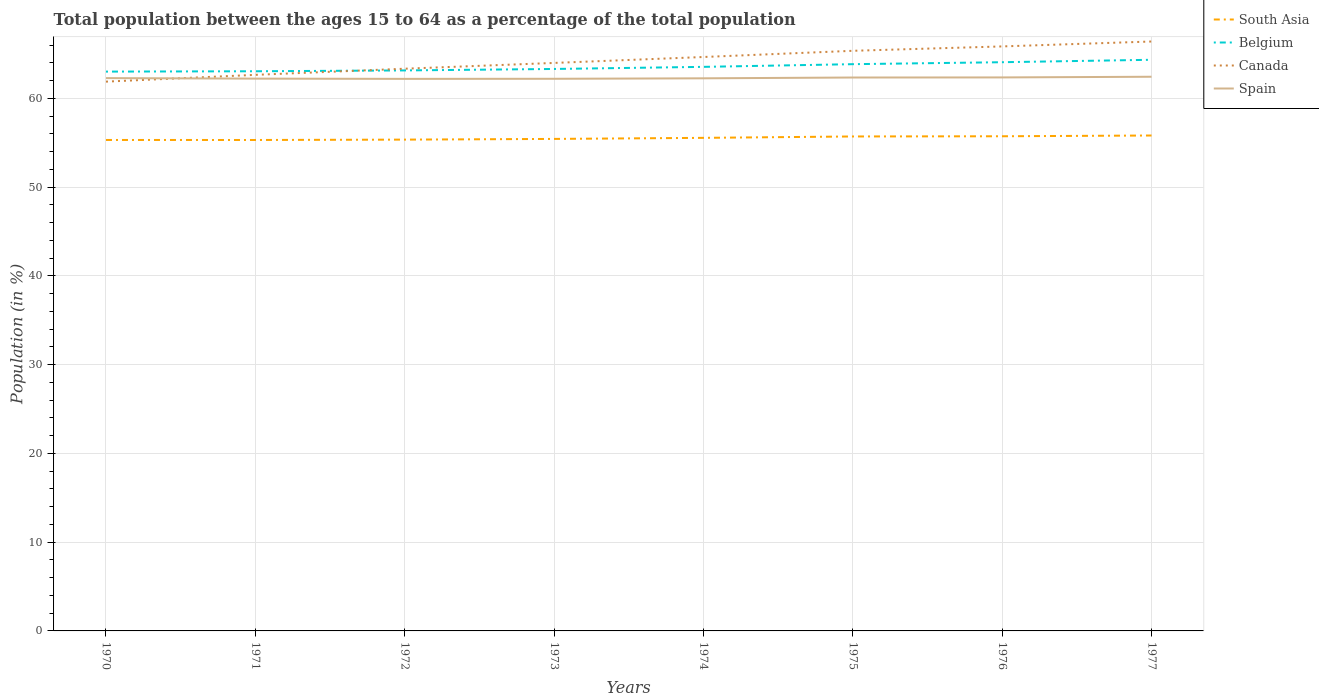Across all years, what is the maximum percentage of the population ages 15 to 64 in South Asia?
Make the answer very short. 55.31. What is the total percentage of the population ages 15 to 64 in South Asia in the graph?
Your answer should be very brief. -0.12. What is the difference between the highest and the second highest percentage of the population ages 15 to 64 in Belgium?
Keep it short and to the point. 1.33. Is the percentage of the population ages 15 to 64 in Spain strictly greater than the percentage of the population ages 15 to 64 in Belgium over the years?
Your answer should be compact. Yes. How many lines are there?
Your answer should be very brief. 4. Does the graph contain grids?
Offer a very short reply. Yes. How many legend labels are there?
Give a very brief answer. 4. How are the legend labels stacked?
Your response must be concise. Vertical. What is the title of the graph?
Your answer should be very brief. Total population between the ages 15 to 64 as a percentage of the total population. Does "United Arab Emirates" appear as one of the legend labels in the graph?
Keep it short and to the point. No. What is the label or title of the Y-axis?
Your answer should be compact. Population (in %). What is the Population (in %) in South Asia in 1970?
Offer a very short reply. 55.31. What is the Population (in %) in Belgium in 1970?
Your answer should be very brief. 63.02. What is the Population (in %) of Canada in 1970?
Make the answer very short. 61.89. What is the Population (in %) in Spain in 1970?
Your answer should be very brief. 62.28. What is the Population (in %) of South Asia in 1971?
Keep it short and to the point. 55.31. What is the Population (in %) in Belgium in 1971?
Keep it short and to the point. 63.05. What is the Population (in %) of Canada in 1971?
Give a very brief answer. 62.65. What is the Population (in %) in Spain in 1971?
Provide a succinct answer. 62.23. What is the Population (in %) of South Asia in 1972?
Keep it short and to the point. 55.35. What is the Population (in %) in Belgium in 1972?
Make the answer very short. 63.15. What is the Population (in %) in Canada in 1972?
Your answer should be very brief. 63.34. What is the Population (in %) in Spain in 1972?
Your answer should be compact. 62.2. What is the Population (in %) in South Asia in 1973?
Provide a succinct answer. 55.43. What is the Population (in %) of Belgium in 1973?
Offer a very short reply. 63.31. What is the Population (in %) of Canada in 1973?
Give a very brief answer. 63.99. What is the Population (in %) of Spain in 1973?
Your answer should be very brief. 62.21. What is the Population (in %) in South Asia in 1974?
Make the answer very short. 55.55. What is the Population (in %) of Belgium in 1974?
Offer a terse response. 63.55. What is the Population (in %) in Canada in 1974?
Your answer should be compact. 64.66. What is the Population (in %) in Spain in 1974?
Your answer should be compact. 62.26. What is the Population (in %) of South Asia in 1975?
Offer a very short reply. 55.71. What is the Population (in %) of Belgium in 1975?
Provide a succinct answer. 63.85. What is the Population (in %) in Canada in 1975?
Provide a succinct answer. 65.36. What is the Population (in %) in Spain in 1975?
Offer a very short reply. 62.35. What is the Population (in %) in South Asia in 1976?
Your answer should be very brief. 55.73. What is the Population (in %) in Belgium in 1976?
Your answer should be very brief. 64.07. What is the Population (in %) in Canada in 1976?
Offer a very short reply. 65.85. What is the Population (in %) of Spain in 1976?
Give a very brief answer. 62.36. What is the Population (in %) of South Asia in 1977?
Keep it short and to the point. 55.82. What is the Population (in %) of Belgium in 1977?
Provide a succinct answer. 64.35. What is the Population (in %) of Canada in 1977?
Provide a succinct answer. 66.41. What is the Population (in %) of Spain in 1977?
Provide a short and direct response. 62.44. Across all years, what is the maximum Population (in %) of South Asia?
Your answer should be very brief. 55.82. Across all years, what is the maximum Population (in %) in Belgium?
Offer a very short reply. 64.35. Across all years, what is the maximum Population (in %) in Canada?
Offer a terse response. 66.41. Across all years, what is the maximum Population (in %) in Spain?
Make the answer very short. 62.44. Across all years, what is the minimum Population (in %) in South Asia?
Offer a very short reply. 55.31. Across all years, what is the minimum Population (in %) of Belgium?
Your answer should be compact. 63.02. Across all years, what is the minimum Population (in %) in Canada?
Give a very brief answer. 61.89. Across all years, what is the minimum Population (in %) of Spain?
Give a very brief answer. 62.2. What is the total Population (in %) in South Asia in the graph?
Your response must be concise. 444.22. What is the total Population (in %) of Belgium in the graph?
Offer a very short reply. 508.36. What is the total Population (in %) in Canada in the graph?
Your answer should be compact. 514.16. What is the total Population (in %) of Spain in the graph?
Provide a short and direct response. 498.33. What is the difference between the Population (in %) in South Asia in 1970 and that in 1971?
Provide a short and direct response. 0. What is the difference between the Population (in %) of Belgium in 1970 and that in 1971?
Your answer should be compact. -0.04. What is the difference between the Population (in %) in Canada in 1970 and that in 1971?
Offer a very short reply. -0.76. What is the difference between the Population (in %) in Spain in 1970 and that in 1971?
Make the answer very short. 0.06. What is the difference between the Population (in %) of South Asia in 1970 and that in 1972?
Give a very brief answer. -0.04. What is the difference between the Population (in %) of Belgium in 1970 and that in 1972?
Give a very brief answer. -0.13. What is the difference between the Population (in %) in Canada in 1970 and that in 1972?
Your answer should be very brief. -1.45. What is the difference between the Population (in %) in Spain in 1970 and that in 1972?
Provide a short and direct response. 0.09. What is the difference between the Population (in %) of South Asia in 1970 and that in 1973?
Offer a terse response. -0.12. What is the difference between the Population (in %) of Belgium in 1970 and that in 1973?
Keep it short and to the point. -0.3. What is the difference between the Population (in %) in Canada in 1970 and that in 1973?
Give a very brief answer. -2.11. What is the difference between the Population (in %) in Spain in 1970 and that in 1973?
Provide a succinct answer. 0.08. What is the difference between the Population (in %) of South Asia in 1970 and that in 1974?
Offer a terse response. -0.24. What is the difference between the Population (in %) in Belgium in 1970 and that in 1974?
Offer a very short reply. -0.53. What is the difference between the Population (in %) of Canada in 1970 and that in 1974?
Offer a terse response. -2.78. What is the difference between the Population (in %) of Spain in 1970 and that in 1974?
Provide a short and direct response. 0.02. What is the difference between the Population (in %) of South Asia in 1970 and that in 1975?
Ensure brevity in your answer.  -0.39. What is the difference between the Population (in %) in Belgium in 1970 and that in 1975?
Keep it short and to the point. -0.84. What is the difference between the Population (in %) in Canada in 1970 and that in 1975?
Offer a terse response. -3.47. What is the difference between the Population (in %) of Spain in 1970 and that in 1975?
Provide a short and direct response. -0.07. What is the difference between the Population (in %) of South Asia in 1970 and that in 1976?
Make the answer very short. -0.42. What is the difference between the Population (in %) in Belgium in 1970 and that in 1976?
Ensure brevity in your answer.  -1.06. What is the difference between the Population (in %) in Canada in 1970 and that in 1976?
Your answer should be compact. -3.97. What is the difference between the Population (in %) in Spain in 1970 and that in 1976?
Your response must be concise. -0.08. What is the difference between the Population (in %) of South Asia in 1970 and that in 1977?
Your answer should be compact. -0.5. What is the difference between the Population (in %) of Belgium in 1970 and that in 1977?
Your answer should be compact. -1.33. What is the difference between the Population (in %) in Canada in 1970 and that in 1977?
Make the answer very short. -4.52. What is the difference between the Population (in %) in Spain in 1970 and that in 1977?
Your answer should be very brief. -0.15. What is the difference between the Population (in %) of South Asia in 1971 and that in 1972?
Give a very brief answer. -0.04. What is the difference between the Population (in %) in Belgium in 1971 and that in 1972?
Offer a very short reply. -0.1. What is the difference between the Population (in %) in Canada in 1971 and that in 1972?
Ensure brevity in your answer.  -0.69. What is the difference between the Population (in %) of Spain in 1971 and that in 1972?
Your answer should be compact. 0.03. What is the difference between the Population (in %) in South Asia in 1971 and that in 1973?
Your answer should be very brief. -0.12. What is the difference between the Population (in %) in Belgium in 1971 and that in 1973?
Offer a terse response. -0.26. What is the difference between the Population (in %) of Canada in 1971 and that in 1973?
Offer a very short reply. -1.34. What is the difference between the Population (in %) in Spain in 1971 and that in 1973?
Provide a succinct answer. 0.02. What is the difference between the Population (in %) in South Asia in 1971 and that in 1974?
Give a very brief answer. -0.24. What is the difference between the Population (in %) of Belgium in 1971 and that in 1974?
Offer a very short reply. -0.5. What is the difference between the Population (in %) of Canada in 1971 and that in 1974?
Provide a short and direct response. -2.01. What is the difference between the Population (in %) of Spain in 1971 and that in 1974?
Ensure brevity in your answer.  -0.03. What is the difference between the Population (in %) of South Asia in 1971 and that in 1975?
Offer a terse response. -0.4. What is the difference between the Population (in %) in Belgium in 1971 and that in 1975?
Your response must be concise. -0.8. What is the difference between the Population (in %) in Canada in 1971 and that in 1975?
Offer a very short reply. -2.71. What is the difference between the Population (in %) in Spain in 1971 and that in 1975?
Provide a short and direct response. -0.12. What is the difference between the Population (in %) of South Asia in 1971 and that in 1976?
Your answer should be very brief. -0.42. What is the difference between the Population (in %) in Belgium in 1971 and that in 1976?
Provide a short and direct response. -1.02. What is the difference between the Population (in %) in Canada in 1971 and that in 1976?
Offer a terse response. -3.2. What is the difference between the Population (in %) in Spain in 1971 and that in 1976?
Provide a succinct answer. -0.14. What is the difference between the Population (in %) of South Asia in 1971 and that in 1977?
Ensure brevity in your answer.  -0.51. What is the difference between the Population (in %) of Belgium in 1971 and that in 1977?
Your answer should be compact. -1.29. What is the difference between the Population (in %) of Canada in 1971 and that in 1977?
Make the answer very short. -3.76. What is the difference between the Population (in %) of Spain in 1971 and that in 1977?
Offer a terse response. -0.21. What is the difference between the Population (in %) of South Asia in 1972 and that in 1973?
Give a very brief answer. -0.08. What is the difference between the Population (in %) of Belgium in 1972 and that in 1973?
Ensure brevity in your answer.  -0.16. What is the difference between the Population (in %) in Canada in 1972 and that in 1973?
Provide a succinct answer. -0.65. What is the difference between the Population (in %) of Spain in 1972 and that in 1973?
Your answer should be compact. -0.01. What is the difference between the Population (in %) in South Asia in 1972 and that in 1974?
Ensure brevity in your answer.  -0.2. What is the difference between the Population (in %) of Belgium in 1972 and that in 1974?
Provide a succinct answer. -0.4. What is the difference between the Population (in %) of Canada in 1972 and that in 1974?
Provide a short and direct response. -1.32. What is the difference between the Population (in %) of Spain in 1972 and that in 1974?
Give a very brief answer. -0.06. What is the difference between the Population (in %) of South Asia in 1972 and that in 1975?
Keep it short and to the point. -0.36. What is the difference between the Population (in %) in Belgium in 1972 and that in 1975?
Provide a succinct answer. -0.7. What is the difference between the Population (in %) of Canada in 1972 and that in 1975?
Your response must be concise. -2.02. What is the difference between the Population (in %) of Spain in 1972 and that in 1975?
Your response must be concise. -0.15. What is the difference between the Population (in %) of South Asia in 1972 and that in 1976?
Provide a succinct answer. -0.38. What is the difference between the Population (in %) in Belgium in 1972 and that in 1976?
Provide a succinct answer. -0.92. What is the difference between the Population (in %) in Canada in 1972 and that in 1976?
Offer a very short reply. -2.51. What is the difference between the Population (in %) of Spain in 1972 and that in 1976?
Ensure brevity in your answer.  -0.16. What is the difference between the Population (in %) in South Asia in 1972 and that in 1977?
Give a very brief answer. -0.46. What is the difference between the Population (in %) in Belgium in 1972 and that in 1977?
Make the answer very short. -1.2. What is the difference between the Population (in %) in Canada in 1972 and that in 1977?
Provide a short and direct response. -3.07. What is the difference between the Population (in %) of Spain in 1972 and that in 1977?
Keep it short and to the point. -0.24. What is the difference between the Population (in %) in South Asia in 1973 and that in 1974?
Ensure brevity in your answer.  -0.12. What is the difference between the Population (in %) of Belgium in 1973 and that in 1974?
Make the answer very short. -0.24. What is the difference between the Population (in %) of Canada in 1973 and that in 1974?
Your response must be concise. -0.67. What is the difference between the Population (in %) of Spain in 1973 and that in 1974?
Offer a terse response. -0.05. What is the difference between the Population (in %) of South Asia in 1973 and that in 1975?
Your answer should be very brief. -0.28. What is the difference between the Population (in %) of Belgium in 1973 and that in 1975?
Offer a very short reply. -0.54. What is the difference between the Population (in %) of Canada in 1973 and that in 1975?
Give a very brief answer. -1.37. What is the difference between the Population (in %) in Spain in 1973 and that in 1975?
Your answer should be very brief. -0.14. What is the difference between the Population (in %) in South Asia in 1973 and that in 1976?
Provide a succinct answer. -0.3. What is the difference between the Population (in %) in Belgium in 1973 and that in 1976?
Your answer should be very brief. -0.76. What is the difference between the Population (in %) in Canada in 1973 and that in 1976?
Ensure brevity in your answer.  -1.86. What is the difference between the Population (in %) of Spain in 1973 and that in 1976?
Make the answer very short. -0.15. What is the difference between the Population (in %) of South Asia in 1973 and that in 1977?
Give a very brief answer. -0.38. What is the difference between the Population (in %) in Belgium in 1973 and that in 1977?
Make the answer very short. -1.03. What is the difference between the Population (in %) in Canada in 1973 and that in 1977?
Your answer should be very brief. -2.41. What is the difference between the Population (in %) in Spain in 1973 and that in 1977?
Offer a very short reply. -0.23. What is the difference between the Population (in %) of South Asia in 1974 and that in 1975?
Ensure brevity in your answer.  -0.16. What is the difference between the Population (in %) in Belgium in 1974 and that in 1975?
Give a very brief answer. -0.3. What is the difference between the Population (in %) in Canada in 1974 and that in 1975?
Ensure brevity in your answer.  -0.7. What is the difference between the Population (in %) in Spain in 1974 and that in 1975?
Give a very brief answer. -0.09. What is the difference between the Population (in %) of South Asia in 1974 and that in 1976?
Your response must be concise. -0.18. What is the difference between the Population (in %) in Belgium in 1974 and that in 1976?
Give a very brief answer. -0.52. What is the difference between the Population (in %) in Canada in 1974 and that in 1976?
Your answer should be very brief. -1.19. What is the difference between the Population (in %) of Spain in 1974 and that in 1976?
Your answer should be very brief. -0.1. What is the difference between the Population (in %) of South Asia in 1974 and that in 1977?
Give a very brief answer. -0.26. What is the difference between the Population (in %) in Belgium in 1974 and that in 1977?
Keep it short and to the point. -0.8. What is the difference between the Population (in %) in Canada in 1974 and that in 1977?
Your answer should be very brief. -1.75. What is the difference between the Population (in %) in Spain in 1974 and that in 1977?
Your answer should be compact. -0.18. What is the difference between the Population (in %) in South Asia in 1975 and that in 1976?
Offer a very short reply. -0.02. What is the difference between the Population (in %) of Belgium in 1975 and that in 1976?
Offer a very short reply. -0.22. What is the difference between the Population (in %) in Canada in 1975 and that in 1976?
Your answer should be compact. -0.49. What is the difference between the Population (in %) of Spain in 1975 and that in 1976?
Your answer should be compact. -0.01. What is the difference between the Population (in %) of South Asia in 1975 and that in 1977?
Ensure brevity in your answer.  -0.11. What is the difference between the Population (in %) in Belgium in 1975 and that in 1977?
Keep it short and to the point. -0.5. What is the difference between the Population (in %) of Canada in 1975 and that in 1977?
Offer a terse response. -1.05. What is the difference between the Population (in %) of Spain in 1975 and that in 1977?
Provide a short and direct response. -0.09. What is the difference between the Population (in %) in South Asia in 1976 and that in 1977?
Give a very brief answer. -0.09. What is the difference between the Population (in %) in Belgium in 1976 and that in 1977?
Give a very brief answer. -0.27. What is the difference between the Population (in %) in Canada in 1976 and that in 1977?
Your response must be concise. -0.55. What is the difference between the Population (in %) in Spain in 1976 and that in 1977?
Your answer should be very brief. -0.08. What is the difference between the Population (in %) of South Asia in 1970 and the Population (in %) of Belgium in 1971?
Offer a very short reply. -7.74. What is the difference between the Population (in %) of South Asia in 1970 and the Population (in %) of Canada in 1971?
Your answer should be very brief. -7.34. What is the difference between the Population (in %) of South Asia in 1970 and the Population (in %) of Spain in 1971?
Offer a very short reply. -6.91. What is the difference between the Population (in %) in Belgium in 1970 and the Population (in %) in Canada in 1971?
Keep it short and to the point. 0.36. What is the difference between the Population (in %) of Belgium in 1970 and the Population (in %) of Spain in 1971?
Provide a succinct answer. 0.79. What is the difference between the Population (in %) of Canada in 1970 and the Population (in %) of Spain in 1971?
Keep it short and to the point. -0.34. What is the difference between the Population (in %) in South Asia in 1970 and the Population (in %) in Belgium in 1972?
Provide a succinct answer. -7.84. What is the difference between the Population (in %) of South Asia in 1970 and the Population (in %) of Canada in 1972?
Make the answer very short. -8.03. What is the difference between the Population (in %) in South Asia in 1970 and the Population (in %) in Spain in 1972?
Ensure brevity in your answer.  -6.88. What is the difference between the Population (in %) of Belgium in 1970 and the Population (in %) of Canada in 1972?
Keep it short and to the point. -0.33. What is the difference between the Population (in %) of Belgium in 1970 and the Population (in %) of Spain in 1972?
Keep it short and to the point. 0.82. What is the difference between the Population (in %) in Canada in 1970 and the Population (in %) in Spain in 1972?
Provide a short and direct response. -0.31. What is the difference between the Population (in %) in South Asia in 1970 and the Population (in %) in Belgium in 1973?
Your response must be concise. -8. What is the difference between the Population (in %) in South Asia in 1970 and the Population (in %) in Canada in 1973?
Offer a terse response. -8.68. What is the difference between the Population (in %) of South Asia in 1970 and the Population (in %) of Spain in 1973?
Provide a short and direct response. -6.89. What is the difference between the Population (in %) in Belgium in 1970 and the Population (in %) in Canada in 1973?
Offer a terse response. -0.98. What is the difference between the Population (in %) of Belgium in 1970 and the Population (in %) of Spain in 1973?
Give a very brief answer. 0.81. What is the difference between the Population (in %) of Canada in 1970 and the Population (in %) of Spain in 1973?
Your response must be concise. -0.32. What is the difference between the Population (in %) in South Asia in 1970 and the Population (in %) in Belgium in 1974?
Your answer should be compact. -8.24. What is the difference between the Population (in %) of South Asia in 1970 and the Population (in %) of Canada in 1974?
Provide a short and direct response. -9.35. What is the difference between the Population (in %) of South Asia in 1970 and the Population (in %) of Spain in 1974?
Give a very brief answer. -6.95. What is the difference between the Population (in %) of Belgium in 1970 and the Population (in %) of Canada in 1974?
Make the answer very short. -1.65. What is the difference between the Population (in %) of Belgium in 1970 and the Population (in %) of Spain in 1974?
Provide a short and direct response. 0.76. What is the difference between the Population (in %) of Canada in 1970 and the Population (in %) of Spain in 1974?
Provide a succinct answer. -0.37. What is the difference between the Population (in %) in South Asia in 1970 and the Population (in %) in Belgium in 1975?
Make the answer very short. -8.54. What is the difference between the Population (in %) of South Asia in 1970 and the Population (in %) of Canada in 1975?
Keep it short and to the point. -10.05. What is the difference between the Population (in %) in South Asia in 1970 and the Population (in %) in Spain in 1975?
Provide a short and direct response. -7.04. What is the difference between the Population (in %) in Belgium in 1970 and the Population (in %) in Canada in 1975?
Offer a very short reply. -2.34. What is the difference between the Population (in %) of Belgium in 1970 and the Population (in %) of Spain in 1975?
Give a very brief answer. 0.67. What is the difference between the Population (in %) of Canada in 1970 and the Population (in %) of Spain in 1975?
Ensure brevity in your answer.  -0.46. What is the difference between the Population (in %) of South Asia in 1970 and the Population (in %) of Belgium in 1976?
Provide a short and direct response. -8.76. What is the difference between the Population (in %) in South Asia in 1970 and the Population (in %) in Canada in 1976?
Make the answer very short. -10.54. What is the difference between the Population (in %) in South Asia in 1970 and the Population (in %) in Spain in 1976?
Provide a succinct answer. -7.05. What is the difference between the Population (in %) in Belgium in 1970 and the Population (in %) in Canada in 1976?
Your answer should be very brief. -2.84. What is the difference between the Population (in %) of Belgium in 1970 and the Population (in %) of Spain in 1976?
Your response must be concise. 0.65. What is the difference between the Population (in %) of Canada in 1970 and the Population (in %) of Spain in 1976?
Make the answer very short. -0.47. What is the difference between the Population (in %) of South Asia in 1970 and the Population (in %) of Belgium in 1977?
Provide a short and direct response. -9.03. What is the difference between the Population (in %) of South Asia in 1970 and the Population (in %) of Canada in 1977?
Keep it short and to the point. -11.09. What is the difference between the Population (in %) of South Asia in 1970 and the Population (in %) of Spain in 1977?
Give a very brief answer. -7.12. What is the difference between the Population (in %) in Belgium in 1970 and the Population (in %) in Canada in 1977?
Your answer should be compact. -3.39. What is the difference between the Population (in %) of Belgium in 1970 and the Population (in %) of Spain in 1977?
Your response must be concise. 0.58. What is the difference between the Population (in %) of Canada in 1970 and the Population (in %) of Spain in 1977?
Your response must be concise. -0.55. What is the difference between the Population (in %) in South Asia in 1971 and the Population (in %) in Belgium in 1972?
Provide a succinct answer. -7.84. What is the difference between the Population (in %) in South Asia in 1971 and the Population (in %) in Canada in 1972?
Ensure brevity in your answer.  -8.03. What is the difference between the Population (in %) of South Asia in 1971 and the Population (in %) of Spain in 1972?
Your answer should be compact. -6.89. What is the difference between the Population (in %) in Belgium in 1971 and the Population (in %) in Canada in 1972?
Offer a terse response. -0.29. What is the difference between the Population (in %) of Belgium in 1971 and the Population (in %) of Spain in 1972?
Give a very brief answer. 0.86. What is the difference between the Population (in %) of Canada in 1971 and the Population (in %) of Spain in 1972?
Provide a short and direct response. 0.45. What is the difference between the Population (in %) in South Asia in 1971 and the Population (in %) in Belgium in 1973?
Offer a terse response. -8. What is the difference between the Population (in %) of South Asia in 1971 and the Population (in %) of Canada in 1973?
Offer a terse response. -8.68. What is the difference between the Population (in %) in South Asia in 1971 and the Population (in %) in Spain in 1973?
Provide a short and direct response. -6.9. What is the difference between the Population (in %) in Belgium in 1971 and the Population (in %) in Canada in 1973?
Provide a short and direct response. -0.94. What is the difference between the Population (in %) in Belgium in 1971 and the Population (in %) in Spain in 1973?
Offer a very short reply. 0.85. What is the difference between the Population (in %) of Canada in 1971 and the Population (in %) of Spain in 1973?
Keep it short and to the point. 0.44. What is the difference between the Population (in %) in South Asia in 1971 and the Population (in %) in Belgium in 1974?
Make the answer very short. -8.24. What is the difference between the Population (in %) of South Asia in 1971 and the Population (in %) of Canada in 1974?
Your response must be concise. -9.35. What is the difference between the Population (in %) in South Asia in 1971 and the Population (in %) in Spain in 1974?
Make the answer very short. -6.95. What is the difference between the Population (in %) in Belgium in 1971 and the Population (in %) in Canada in 1974?
Your answer should be compact. -1.61. What is the difference between the Population (in %) in Belgium in 1971 and the Population (in %) in Spain in 1974?
Your response must be concise. 0.79. What is the difference between the Population (in %) of Canada in 1971 and the Population (in %) of Spain in 1974?
Your answer should be very brief. 0.39. What is the difference between the Population (in %) in South Asia in 1971 and the Population (in %) in Belgium in 1975?
Make the answer very short. -8.54. What is the difference between the Population (in %) of South Asia in 1971 and the Population (in %) of Canada in 1975?
Ensure brevity in your answer.  -10.05. What is the difference between the Population (in %) in South Asia in 1971 and the Population (in %) in Spain in 1975?
Ensure brevity in your answer.  -7.04. What is the difference between the Population (in %) in Belgium in 1971 and the Population (in %) in Canada in 1975?
Offer a very short reply. -2.31. What is the difference between the Population (in %) of Belgium in 1971 and the Population (in %) of Spain in 1975?
Keep it short and to the point. 0.7. What is the difference between the Population (in %) of Canada in 1971 and the Population (in %) of Spain in 1975?
Your answer should be very brief. 0.3. What is the difference between the Population (in %) of South Asia in 1971 and the Population (in %) of Belgium in 1976?
Provide a succinct answer. -8.76. What is the difference between the Population (in %) of South Asia in 1971 and the Population (in %) of Canada in 1976?
Your answer should be very brief. -10.54. What is the difference between the Population (in %) of South Asia in 1971 and the Population (in %) of Spain in 1976?
Provide a short and direct response. -7.05. What is the difference between the Population (in %) of Belgium in 1971 and the Population (in %) of Canada in 1976?
Provide a succinct answer. -2.8. What is the difference between the Population (in %) in Belgium in 1971 and the Population (in %) in Spain in 1976?
Keep it short and to the point. 0.69. What is the difference between the Population (in %) of Canada in 1971 and the Population (in %) of Spain in 1976?
Make the answer very short. 0.29. What is the difference between the Population (in %) in South Asia in 1971 and the Population (in %) in Belgium in 1977?
Offer a terse response. -9.04. What is the difference between the Population (in %) in South Asia in 1971 and the Population (in %) in Canada in 1977?
Offer a very short reply. -11.1. What is the difference between the Population (in %) of South Asia in 1971 and the Population (in %) of Spain in 1977?
Provide a succinct answer. -7.13. What is the difference between the Population (in %) in Belgium in 1971 and the Population (in %) in Canada in 1977?
Your response must be concise. -3.35. What is the difference between the Population (in %) of Belgium in 1971 and the Population (in %) of Spain in 1977?
Offer a terse response. 0.62. What is the difference between the Population (in %) of Canada in 1971 and the Population (in %) of Spain in 1977?
Offer a very short reply. 0.21. What is the difference between the Population (in %) of South Asia in 1972 and the Population (in %) of Belgium in 1973?
Give a very brief answer. -7.96. What is the difference between the Population (in %) of South Asia in 1972 and the Population (in %) of Canada in 1973?
Provide a short and direct response. -8.64. What is the difference between the Population (in %) of South Asia in 1972 and the Population (in %) of Spain in 1973?
Offer a terse response. -6.86. What is the difference between the Population (in %) of Belgium in 1972 and the Population (in %) of Canada in 1973?
Provide a short and direct response. -0.84. What is the difference between the Population (in %) in Belgium in 1972 and the Population (in %) in Spain in 1973?
Your response must be concise. 0.94. What is the difference between the Population (in %) in Canada in 1972 and the Population (in %) in Spain in 1973?
Your response must be concise. 1.13. What is the difference between the Population (in %) of South Asia in 1972 and the Population (in %) of Belgium in 1974?
Provide a short and direct response. -8.2. What is the difference between the Population (in %) of South Asia in 1972 and the Population (in %) of Canada in 1974?
Provide a short and direct response. -9.31. What is the difference between the Population (in %) in South Asia in 1972 and the Population (in %) in Spain in 1974?
Provide a short and direct response. -6.91. What is the difference between the Population (in %) of Belgium in 1972 and the Population (in %) of Canada in 1974?
Provide a succinct answer. -1.51. What is the difference between the Population (in %) in Belgium in 1972 and the Population (in %) in Spain in 1974?
Make the answer very short. 0.89. What is the difference between the Population (in %) of Canada in 1972 and the Population (in %) of Spain in 1974?
Your answer should be compact. 1.08. What is the difference between the Population (in %) of South Asia in 1972 and the Population (in %) of Belgium in 1975?
Provide a succinct answer. -8.5. What is the difference between the Population (in %) of South Asia in 1972 and the Population (in %) of Canada in 1975?
Keep it short and to the point. -10.01. What is the difference between the Population (in %) of South Asia in 1972 and the Population (in %) of Spain in 1975?
Offer a terse response. -7. What is the difference between the Population (in %) in Belgium in 1972 and the Population (in %) in Canada in 1975?
Your answer should be compact. -2.21. What is the difference between the Population (in %) in Belgium in 1972 and the Population (in %) in Spain in 1975?
Make the answer very short. 0.8. What is the difference between the Population (in %) of Canada in 1972 and the Population (in %) of Spain in 1975?
Ensure brevity in your answer.  0.99. What is the difference between the Population (in %) of South Asia in 1972 and the Population (in %) of Belgium in 1976?
Your answer should be compact. -8.72. What is the difference between the Population (in %) of South Asia in 1972 and the Population (in %) of Canada in 1976?
Make the answer very short. -10.5. What is the difference between the Population (in %) in South Asia in 1972 and the Population (in %) in Spain in 1976?
Keep it short and to the point. -7.01. What is the difference between the Population (in %) of Belgium in 1972 and the Population (in %) of Canada in 1976?
Your answer should be compact. -2.7. What is the difference between the Population (in %) of Belgium in 1972 and the Population (in %) of Spain in 1976?
Make the answer very short. 0.79. What is the difference between the Population (in %) in Canada in 1972 and the Population (in %) in Spain in 1976?
Ensure brevity in your answer.  0.98. What is the difference between the Population (in %) in South Asia in 1972 and the Population (in %) in Belgium in 1977?
Provide a succinct answer. -9. What is the difference between the Population (in %) of South Asia in 1972 and the Population (in %) of Canada in 1977?
Your answer should be very brief. -11.05. What is the difference between the Population (in %) in South Asia in 1972 and the Population (in %) in Spain in 1977?
Your answer should be compact. -7.08. What is the difference between the Population (in %) of Belgium in 1972 and the Population (in %) of Canada in 1977?
Your answer should be compact. -3.26. What is the difference between the Population (in %) of Belgium in 1972 and the Population (in %) of Spain in 1977?
Offer a terse response. 0.71. What is the difference between the Population (in %) in Canada in 1972 and the Population (in %) in Spain in 1977?
Your answer should be very brief. 0.9. What is the difference between the Population (in %) in South Asia in 1973 and the Population (in %) in Belgium in 1974?
Provide a succinct answer. -8.12. What is the difference between the Population (in %) of South Asia in 1973 and the Population (in %) of Canada in 1974?
Offer a terse response. -9.23. What is the difference between the Population (in %) in South Asia in 1973 and the Population (in %) in Spain in 1974?
Your answer should be very brief. -6.83. What is the difference between the Population (in %) in Belgium in 1973 and the Population (in %) in Canada in 1974?
Your answer should be compact. -1.35. What is the difference between the Population (in %) in Belgium in 1973 and the Population (in %) in Spain in 1974?
Provide a short and direct response. 1.05. What is the difference between the Population (in %) in Canada in 1973 and the Population (in %) in Spain in 1974?
Your answer should be compact. 1.73. What is the difference between the Population (in %) of South Asia in 1973 and the Population (in %) of Belgium in 1975?
Ensure brevity in your answer.  -8.42. What is the difference between the Population (in %) in South Asia in 1973 and the Population (in %) in Canada in 1975?
Make the answer very short. -9.93. What is the difference between the Population (in %) of South Asia in 1973 and the Population (in %) of Spain in 1975?
Provide a succinct answer. -6.92. What is the difference between the Population (in %) of Belgium in 1973 and the Population (in %) of Canada in 1975?
Your answer should be very brief. -2.05. What is the difference between the Population (in %) of Belgium in 1973 and the Population (in %) of Spain in 1975?
Ensure brevity in your answer.  0.96. What is the difference between the Population (in %) in Canada in 1973 and the Population (in %) in Spain in 1975?
Offer a very short reply. 1.64. What is the difference between the Population (in %) in South Asia in 1973 and the Population (in %) in Belgium in 1976?
Provide a short and direct response. -8.64. What is the difference between the Population (in %) in South Asia in 1973 and the Population (in %) in Canada in 1976?
Your answer should be compact. -10.42. What is the difference between the Population (in %) in South Asia in 1973 and the Population (in %) in Spain in 1976?
Ensure brevity in your answer.  -6.93. What is the difference between the Population (in %) of Belgium in 1973 and the Population (in %) of Canada in 1976?
Give a very brief answer. -2.54. What is the difference between the Population (in %) in Belgium in 1973 and the Population (in %) in Spain in 1976?
Keep it short and to the point. 0.95. What is the difference between the Population (in %) of Canada in 1973 and the Population (in %) of Spain in 1976?
Keep it short and to the point. 1.63. What is the difference between the Population (in %) of South Asia in 1973 and the Population (in %) of Belgium in 1977?
Your response must be concise. -8.92. What is the difference between the Population (in %) of South Asia in 1973 and the Population (in %) of Canada in 1977?
Your answer should be very brief. -10.98. What is the difference between the Population (in %) in South Asia in 1973 and the Population (in %) in Spain in 1977?
Your answer should be very brief. -7. What is the difference between the Population (in %) of Belgium in 1973 and the Population (in %) of Canada in 1977?
Offer a terse response. -3.09. What is the difference between the Population (in %) in Belgium in 1973 and the Population (in %) in Spain in 1977?
Make the answer very short. 0.88. What is the difference between the Population (in %) of Canada in 1973 and the Population (in %) of Spain in 1977?
Give a very brief answer. 1.56. What is the difference between the Population (in %) in South Asia in 1974 and the Population (in %) in Belgium in 1975?
Your answer should be very brief. -8.3. What is the difference between the Population (in %) of South Asia in 1974 and the Population (in %) of Canada in 1975?
Your answer should be very brief. -9.81. What is the difference between the Population (in %) of South Asia in 1974 and the Population (in %) of Spain in 1975?
Your response must be concise. -6.8. What is the difference between the Population (in %) in Belgium in 1974 and the Population (in %) in Canada in 1975?
Your response must be concise. -1.81. What is the difference between the Population (in %) of Belgium in 1974 and the Population (in %) of Spain in 1975?
Give a very brief answer. 1.2. What is the difference between the Population (in %) in Canada in 1974 and the Population (in %) in Spain in 1975?
Offer a terse response. 2.31. What is the difference between the Population (in %) in South Asia in 1974 and the Population (in %) in Belgium in 1976?
Your answer should be very brief. -8.52. What is the difference between the Population (in %) of South Asia in 1974 and the Population (in %) of Canada in 1976?
Your answer should be very brief. -10.3. What is the difference between the Population (in %) in South Asia in 1974 and the Population (in %) in Spain in 1976?
Offer a very short reply. -6.81. What is the difference between the Population (in %) in Belgium in 1974 and the Population (in %) in Canada in 1976?
Ensure brevity in your answer.  -2.3. What is the difference between the Population (in %) in Belgium in 1974 and the Population (in %) in Spain in 1976?
Offer a terse response. 1.19. What is the difference between the Population (in %) in Canada in 1974 and the Population (in %) in Spain in 1976?
Your answer should be compact. 2.3. What is the difference between the Population (in %) of South Asia in 1974 and the Population (in %) of Belgium in 1977?
Keep it short and to the point. -8.8. What is the difference between the Population (in %) in South Asia in 1974 and the Population (in %) in Canada in 1977?
Give a very brief answer. -10.86. What is the difference between the Population (in %) of South Asia in 1974 and the Population (in %) of Spain in 1977?
Offer a very short reply. -6.88. What is the difference between the Population (in %) of Belgium in 1974 and the Population (in %) of Canada in 1977?
Your response must be concise. -2.86. What is the difference between the Population (in %) of Belgium in 1974 and the Population (in %) of Spain in 1977?
Keep it short and to the point. 1.11. What is the difference between the Population (in %) in Canada in 1974 and the Population (in %) in Spain in 1977?
Ensure brevity in your answer.  2.22. What is the difference between the Population (in %) of South Asia in 1975 and the Population (in %) of Belgium in 1976?
Give a very brief answer. -8.37. What is the difference between the Population (in %) in South Asia in 1975 and the Population (in %) in Canada in 1976?
Your response must be concise. -10.15. What is the difference between the Population (in %) of South Asia in 1975 and the Population (in %) of Spain in 1976?
Make the answer very short. -6.65. What is the difference between the Population (in %) of Belgium in 1975 and the Population (in %) of Canada in 1976?
Your response must be concise. -2. What is the difference between the Population (in %) of Belgium in 1975 and the Population (in %) of Spain in 1976?
Provide a short and direct response. 1.49. What is the difference between the Population (in %) in Canada in 1975 and the Population (in %) in Spain in 1976?
Make the answer very short. 3. What is the difference between the Population (in %) in South Asia in 1975 and the Population (in %) in Belgium in 1977?
Give a very brief answer. -8.64. What is the difference between the Population (in %) in South Asia in 1975 and the Population (in %) in Canada in 1977?
Make the answer very short. -10.7. What is the difference between the Population (in %) in South Asia in 1975 and the Population (in %) in Spain in 1977?
Provide a succinct answer. -6.73. What is the difference between the Population (in %) of Belgium in 1975 and the Population (in %) of Canada in 1977?
Keep it short and to the point. -2.55. What is the difference between the Population (in %) of Belgium in 1975 and the Population (in %) of Spain in 1977?
Your answer should be compact. 1.42. What is the difference between the Population (in %) of Canada in 1975 and the Population (in %) of Spain in 1977?
Your answer should be very brief. 2.92. What is the difference between the Population (in %) of South Asia in 1976 and the Population (in %) of Belgium in 1977?
Ensure brevity in your answer.  -8.62. What is the difference between the Population (in %) of South Asia in 1976 and the Population (in %) of Canada in 1977?
Your answer should be very brief. -10.68. What is the difference between the Population (in %) in South Asia in 1976 and the Population (in %) in Spain in 1977?
Your answer should be compact. -6.71. What is the difference between the Population (in %) in Belgium in 1976 and the Population (in %) in Canada in 1977?
Ensure brevity in your answer.  -2.33. What is the difference between the Population (in %) in Belgium in 1976 and the Population (in %) in Spain in 1977?
Your response must be concise. 1.64. What is the difference between the Population (in %) in Canada in 1976 and the Population (in %) in Spain in 1977?
Your response must be concise. 3.42. What is the average Population (in %) in South Asia per year?
Make the answer very short. 55.53. What is the average Population (in %) in Belgium per year?
Make the answer very short. 63.55. What is the average Population (in %) in Canada per year?
Give a very brief answer. 64.27. What is the average Population (in %) in Spain per year?
Offer a very short reply. 62.29. In the year 1970, what is the difference between the Population (in %) of South Asia and Population (in %) of Belgium?
Provide a succinct answer. -7.7. In the year 1970, what is the difference between the Population (in %) of South Asia and Population (in %) of Canada?
Make the answer very short. -6.57. In the year 1970, what is the difference between the Population (in %) in South Asia and Population (in %) in Spain?
Provide a short and direct response. -6.97. In the year 1970, what is the difference between the Population (in %) of Belgium and Population (in %) of Canada?
Provide a short and direct response. 1.13. In the year 1970, what is the difference between the Population (in %) in Belgium and Population (in %) in Spain?
Keep it short and to the point. 0.73. In the year 1970, what is the difference between the Population (in %) in Canada and Population (in %) in Spain?
Offer a terse response. -0.4. In the year 1971, what is the difference between the Population (in %) of South Asia and Population (in %) of Belgium?
Provide a succinct answer. -7.74. In the year 1971, what is the difference between the Population (in %) of South Asia and Population (in %) of Canada?
Your answer should be very brief. -7.34. In the year 1971, what is the difference between the Population (in %) in South Asia and Population (in %) in Spain?
Ensure brevity in your answer.  -6.91. In the year 1971, what is the difference between the Population (in %) of Belgium and Population (in %) of Canada?
Your response must be concise. 0.4. In the year 1971, what is the difference between the Population (in %) in Belgium and Population (in %) in Spain?
Your answer should be compact. 0.83. In the year 1971, what is the difference between the Population (in %) of Canada and Population (in %) of Spain?
Ensure brevity in your answer.  0.43. In the year 1972, what is the difference between the Population (in %) in South Asia and Population (in %) in Belgium?
Offer a terse response. -7.8. In the year 1972, what is the difference between the Population (in %) in South Asia and Population (in %) in Canada?
Make the answer very short. -7.99. In the year 1972, what is the difference between the Population (in %) in South Asia and Population (in %) in Spain?
Offer a terse response. -6.84. In the year 1972, what is the difference between the Population (in %) in Belgium and Population (in %) in Canada?
Make the answer very short. -0.19. In the year 1972, what is the difference between the Population (in %) in Belgium and Population (in %) in Spain?
Offer a terse response. 0.95. In the year 1972, what is the difference between the Population (in %) of Canada and Population (in %) of Spain?
Give a very brief answer. 1.14. In the year 1973, what is the difference between the Population (in %) in South Asia and Population (in %) in Belgium?
Offer a very short reply. -7.88. In the year 1973, what is the difference between the Population (in %) in South Asia and Population (in %) in Canada?
Your answer should be very brief. -8.56. In the year 1973, what is the difference between the Population (in %) in South Asia and Population (in %) in Spain?
Offer a very short reply. -6.78. In the year 1973, what is the difference between the Population (in %) of Belgium and Population (in %) of Canada?
Ensure brevity in your answer.  -0.68. In the year 1973, what is the difference between the Population (in %) of Belgium and Population (in %) of Spain?
Offer a very short reply. 1.11. In the year 1973, what is the difference between the Population (in %) of Canada and Population (in %) of Spain?
Your response must be concise. 1.79. In the year 1974, what is the difference between the Population (in %) of South Asia and Population (in %) of Belgium?
Your response must be concise. -8. In the year 1974, what is the difference between the Population (in %) of South Asia and Population (in %) of Canada?
Your answer should be very brief. -9.11. In the year 1974, what is the difference between the Population (in %) in South Asia and Population (in %) in Spain?
Offer a terse response. -6.71. In the year 1974, what is the difference between the Population (in %) in Belgium and Population (in %) in Canada?
Offer a very short reply. -1.11. In the year 1974, what is the difference between the Population (in %) in Belgium and Population (in %) in Spain?
Your answer should be compact. 1.29. In the year 1974, what is the difference between the Population (in %) in Canada and Population (in %) in Spain?
Offer a terse response. 2.4. In the year 1975, what is the difference between the Population (in %) in South Asia and Population (in %) in Belgium?
Offer a terse response. -8.14. In the year 1975, what is the difference between the Population (in %) in South Asia and Population (in %) in Canada?
Make the answer very short. -9.65. In the year 1975, what is the difference between the Population (in %) in South Asia and Population (in %) in Spain?
Offer a terse response. -6.64. In the year 1975, what is the difference between the Population (in %) of Belgium and Population (in %) of Canada?
Provide a short and direct response. -1.51. In the year 1975, what is the difference between the Population (in %) in Belgium and Population (in %) in Spain?
Make the answer very short. 1.5. In the year 1975, what is the difference between the Population (in %) in Canada and Population (in %) in Spain?
Give a very brief answer. 3.01. In the year 1976, what is the difference between the Population (in %) in South Asia and Population (in %) in Belgium?
Offer a terse response. -8.34. In the year 1976, what is the difference between the Population (in %) of South Asia and Population (in %) of Canada?
Ensure brevity in your answer.  -10.12. In the year 1976, what is the difference between the Population (in %) of South Asia and Population (in %) of Spain?
Give a very brief answer. -6.63. In the year 1976, what is the difference between the Population (in %) of Belgium and Population (in %) of Canada?
Your answer should be very brief. -1.78. In the year 1976, what is the difference between the Population (in %) of Belgium and Population (in %) of Spain?
Offer a very short reply. 1.71. In the year 1976, what is the difference between the Population (in %) in Canada and Population (in %) in Spain?
Keep it short and to the point. 3.49. In the year 1977, what is the difference between the Population (in %) of South Asia and Population (in %) of Belgium?
Provide a succinct answer. -8.53. In the year 1977, what is the difference between the Population (in %) of South Asia and Population (in %) of Canada?
Keep it short and to the point. -10.59. In the year 1977, what is the difference between the Population (in %) in South Asia and Population (in %) in Spain?
Provide a short and direct response. -6.62. In the year 1977, what is the difference between the Population (in %) of Belgium and Population (in %) of Canada?
Offer a terse response. -2.06. In the year 1977, what is the difference between the Population (in %) in Belgium and Population (in %) in Spain?
Keep it short and to the point. 1.91. In the year 1977, what is the difference between the Population (in %) of Canada and Population (in %) of Spain?
Ensure brevity in your answer.  3.97. What is the ratio of the Population (in %) in Belgium in 1970 to that in 1971?
Offer a terse response. 1. What is the ratio of the Population (in %) of Canada in 1970 to that in 1971?
Provide a short and direct response. 0.99. What is the ratio of the Population (in %) of Belgium in 1970 to that in 1972?
Offer a terse response. 1. What is the ratio of the Population (in %) of Canada in 1970 to that in 1972?
Offer a terse response. 0.98. What is the ratio of the Population (in %) in Belgium in 1970 to that in 1973?
Offer a terse response. 1. What is the ratio of the Population (in %) in Canada in 1970 to that in 1973?
Your answer should be compact. 0.97. What is the ratio of the Population (in %) of Spain in 1970 to that in 1973?
Offer a terse response. 1. What is the ratio of the Population (in %) in Canada in 1970 to that in 1974?
Your answer should be very brief. 0.96. What is the ratio of the Population (in %) in Spain in 1970 to that in 1974?
Provide a short and direct response. 1. What is the ratio of the Population (in %) in Belgium in 1970 to that in 1975?
Offer a very short reply. 0.99. What is the ratio of the Population (in %) in Canada in 1970 to that in 1975?
Provide a succinct answer. 0.95. What is the ratio of the Population (in %) of Spain in 1970 to that in 1975?
Offer a terse response. 1. What is the ratio of the Population (in %) in Belgium in 1970 to that in 1976?
Provide a short and direct response. 0.98. What is the ratio of the Population (in %) of Canada in 1970 to that in 1976?
Offer a terse response. 0.94. What is the ratio of the Population (in %) in Spain in 1970 to that in 1976?
Your answer should be very brief. 1. What is the ratio of the Population (in %) of South Asia in 1970 to that in 1977?
Your response must be concise. 0.99. What is the ratio of the Population (in %) in Belgium in 1970 to that in 1977?
Provide a succinct answer. 0.98. What is the ratio of the Population (in %) in Canada in 1970 to that in 1977?
Make the answer very short. 0.93. What is the ratio of the Population (in %) in South Asia in 1971 to that in 1972?
Provide a succinct answer. 1. What is the ratio of the Population (in %) of Belgium in 1971 to that in 1972?
Your answer should be very brief. 1. What is the ratio of the Population (in %) in Canada in 1971 to that in 1972?
Give a very brief answer. 0.99. What is the ratio of the Population (in %) of Belgium in 1971 to that in 1973?
Give a very brief answer. 1. What is the ratio of the Population (in %) of Canada in 1971 to that in 1973?
Make the answer very short. 0.98. What is the ratio of the Population (in %) of South Asia in 1971 to that in 1974?
Your answer should be compact. 1. What is the ratio of the Population (in %) of Belgium in 1971 to that in 1974?
Your response must be concise. 0.99. What is the ratio of the Population (in %) of Canada in 1971 to that in 1974?
Keep it short and to the point. 0.97. What is the ratio of the Population (in %) in Spain in 1971 to that in 1974?
Give a very brief answer. 1. What is the ratio of the Population (in %) of South Asia in 1971 to that in 1975?
Give a very brief answer. 0.99. What is the ratio of the Population (in %) of Belgium in 1971 to that in 1975?
Your response must be concise. 0.99. What is the ratio of the Population (in %) of Canada in 1971 to that in 1975?
Give a very brief answer. 0.96. What is the ratio of the Population (in %) of Spain in 1971 to that in 1975?
Give a very brief answer. 1. What is the ratio of the Population (in %) of South Asia in 1971 to that in 1976?
Your answer should be compact. 0.99. What is the ratio of the Population (in %) of Belgium in 1971 to that in 1976?
Give a very brief answer. 0.98. What is the ratio of the Population (in %) in Canada in 1971 to that in 1976?
Make the answer very short. 0.95. What is the ratio of the Population (in %) in Spain in 1971 to that in 1976?
Make the answer very short. 1. What is the ratio of the Population (in %) of South Asia in 1971 to that in 1977?
Keep it short and to the point. 0.99. What is the ratio of the Population (in %) in Belgium in 1971 to that in 1977?
Your answer should be compact. 0.98. What is the ratio of the Population (in %) of Canada in 1971 to that in 1977?
Your answer should be compact. 0.94. What is the ratio of the Population (in %) in Spain in 1971 to that in 1977?
Offer a very short reply. 1. What is the ratio of the Population (in %) in South Asia in 1972 to that in 1973?
Your answer should be very brief. 1. What is the ratio of the Population (in %) of Belgium in 1972 to that in 1973?
Offer a terse response. 1. What is the ratio of the Population (in %) of Spain in 1972 to that in 1973?
Provide a succinct answer. 1. What is the ratio of the Population (in %) in Belgium in 1972 to that in 1974?
Keep it short and to the point. 0.99. What is the ratio of the Population (in %) in Canada in 1972 to that in 1974?
Offer a terse response. 0.98. What is the ratio of the Population (in %) of South Asia in 1972 to that in 1975?
Give a very brief answer. 0.99. What is the ratio of the Population (in %) in Canada in 1972 to that in 1975?
Offer a terse response. 0.97. What is the ratio of the Population (in %) of Belgium in 1972 to that in 1976?
Your answer should be very brief. 0.99. What is the ratio of the Population (in %) of Canada in 1972 to that in 1976?
Ensure brevity in your answer.  0.96. What is the ratio of the Population (in %) of South Asia in 1972 to that in 1977?
Your response must be concise. 0.99. What is the ratio of the Population (in %) of Belgium in 1972 to that in 1977?
Give a very brief answer. 0.98. What is the ratio of the Population (in %) of Canada in 1972 to that in 1977?
Your response must be concise. 0.95. What is the ratio of the Population (in %) of Canada in 1973 to that in 1974?
Ensure brevity in your answer.  0.99. What is the ratio of the Population (in %) in Canada in 1973 to that in 1975?
Keep it short and to the point. 0.98. What is the ratio of the Population (in %) in Spain in 1973 to that in 1975?
Give a very brief answer. 1. What is the ratio of the Population (in %) in South Asia in 1973 to that in 1976?
Offer a terse response. 0.99. What is the ratio of the Population (in %) of Belgium in 1973 to that in 1976?
Provide a succinct answer. 0.99. What is the ratio of the Population (in %) of Canada in 1973 to that in 1976?
Make the answer very short. 0.97. What is the ratio of the Population (in %) in South Asia in 1973 to that in 1977?
Offer a terse response. 0.99. What is the ratio of the Population (in %) in Belgium in 1973 to that in 1977?
Provide a succinct answer. 0.98. What is the ratio of the Population (in %) of Canada in 1973 to that in 1977?
Your answer should be compact. 0.96. What is the ratio of the Population (in %) in South Asia in 1974 to that in 1975?
Your answer should be compact. 1. What is the ratio of the Population (in %) of Canada in 1974 to that in 1975?
Your response must be concise. 0.99. What is the ratio of the Population (in %) in Belgium in 1974 to that in 1976?
Offer a very short reply. 0.99. What is the ratio of the Population (in %) in Canada in 1974 to that in 1976?
Provide a short and direct response. 0.98. What is the ratio of the Population (in %) in Belgium in 1974 to that in 1977?
Your answer should be very brief. 0.99. What is the ratio of the Population (in %) of Canada in 1974 to that in 1977?
Keep it short and to the point. 0.97. What is the ratio of the Population (in %) in Spain in 1974 to that in 1977?
Give a very brief answer. 1. What is the ratio of the Population (in %) of Belgium in 1975 to that in 1977?
Make the answer very short. 0.99. What is the ratio of the Population (in %) of Canada in 1975 to that in 1977?
Provide a succinct answer. 0.98. What is the ratio of the Population (in %) in Spain in 1975 to that in 1977?
Keep it short and to the point. 1. What is the ratio of the Population (in %) of South Asia in 1976 to that in 1977?
Keep it short and to the point. 1. What is the ratio of the Population (in %) in Belgium in 1976 to that in 1977?
Provide a short and direct response. 1. What is the ratio of the Population (in %) in Canada in 1976 to that in 1977?
Ensure brevity in your answer.  0.99. What is the difference between the highest and the second highest Population (in %) of South Asia?
Provide a short and direct response. 0.09. What is the difference between the highest and the second highest Population (in %) of Belgium?
Offer a very short reply. 0.27. What is the difference between the highest and the second highest Population (in %) in Canada?
Keep it short and to the point. 0.55. What is the difference between the highest and the second highest Population (in %) in Spain?
Provide a short and direct response. 0.08. What is the difference between the highest and the lowest Population (in %) in South Asia?
Keep it short and to the point. 0.51. What is the difference between the highest and the lowest Population (in %) in Belgium?
Provide a short and direct response. 1.33. What is the difference between the highest and the lowest Population (in %) in Canada?
Give a very brief answer. 4.52. What is the difference between the highest and the lowest Population (in %) of Spain?
Your answer should be very brief. 0.24. 